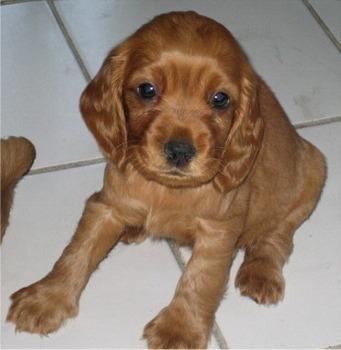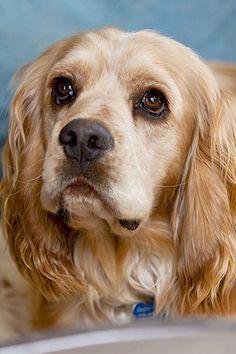The first image is the image on the left, the second image is the image on the right. For the images displayed, is the sentence "There is at least one dog indoors in the image on the left." factually correct? Answer yes or no. Yes. 